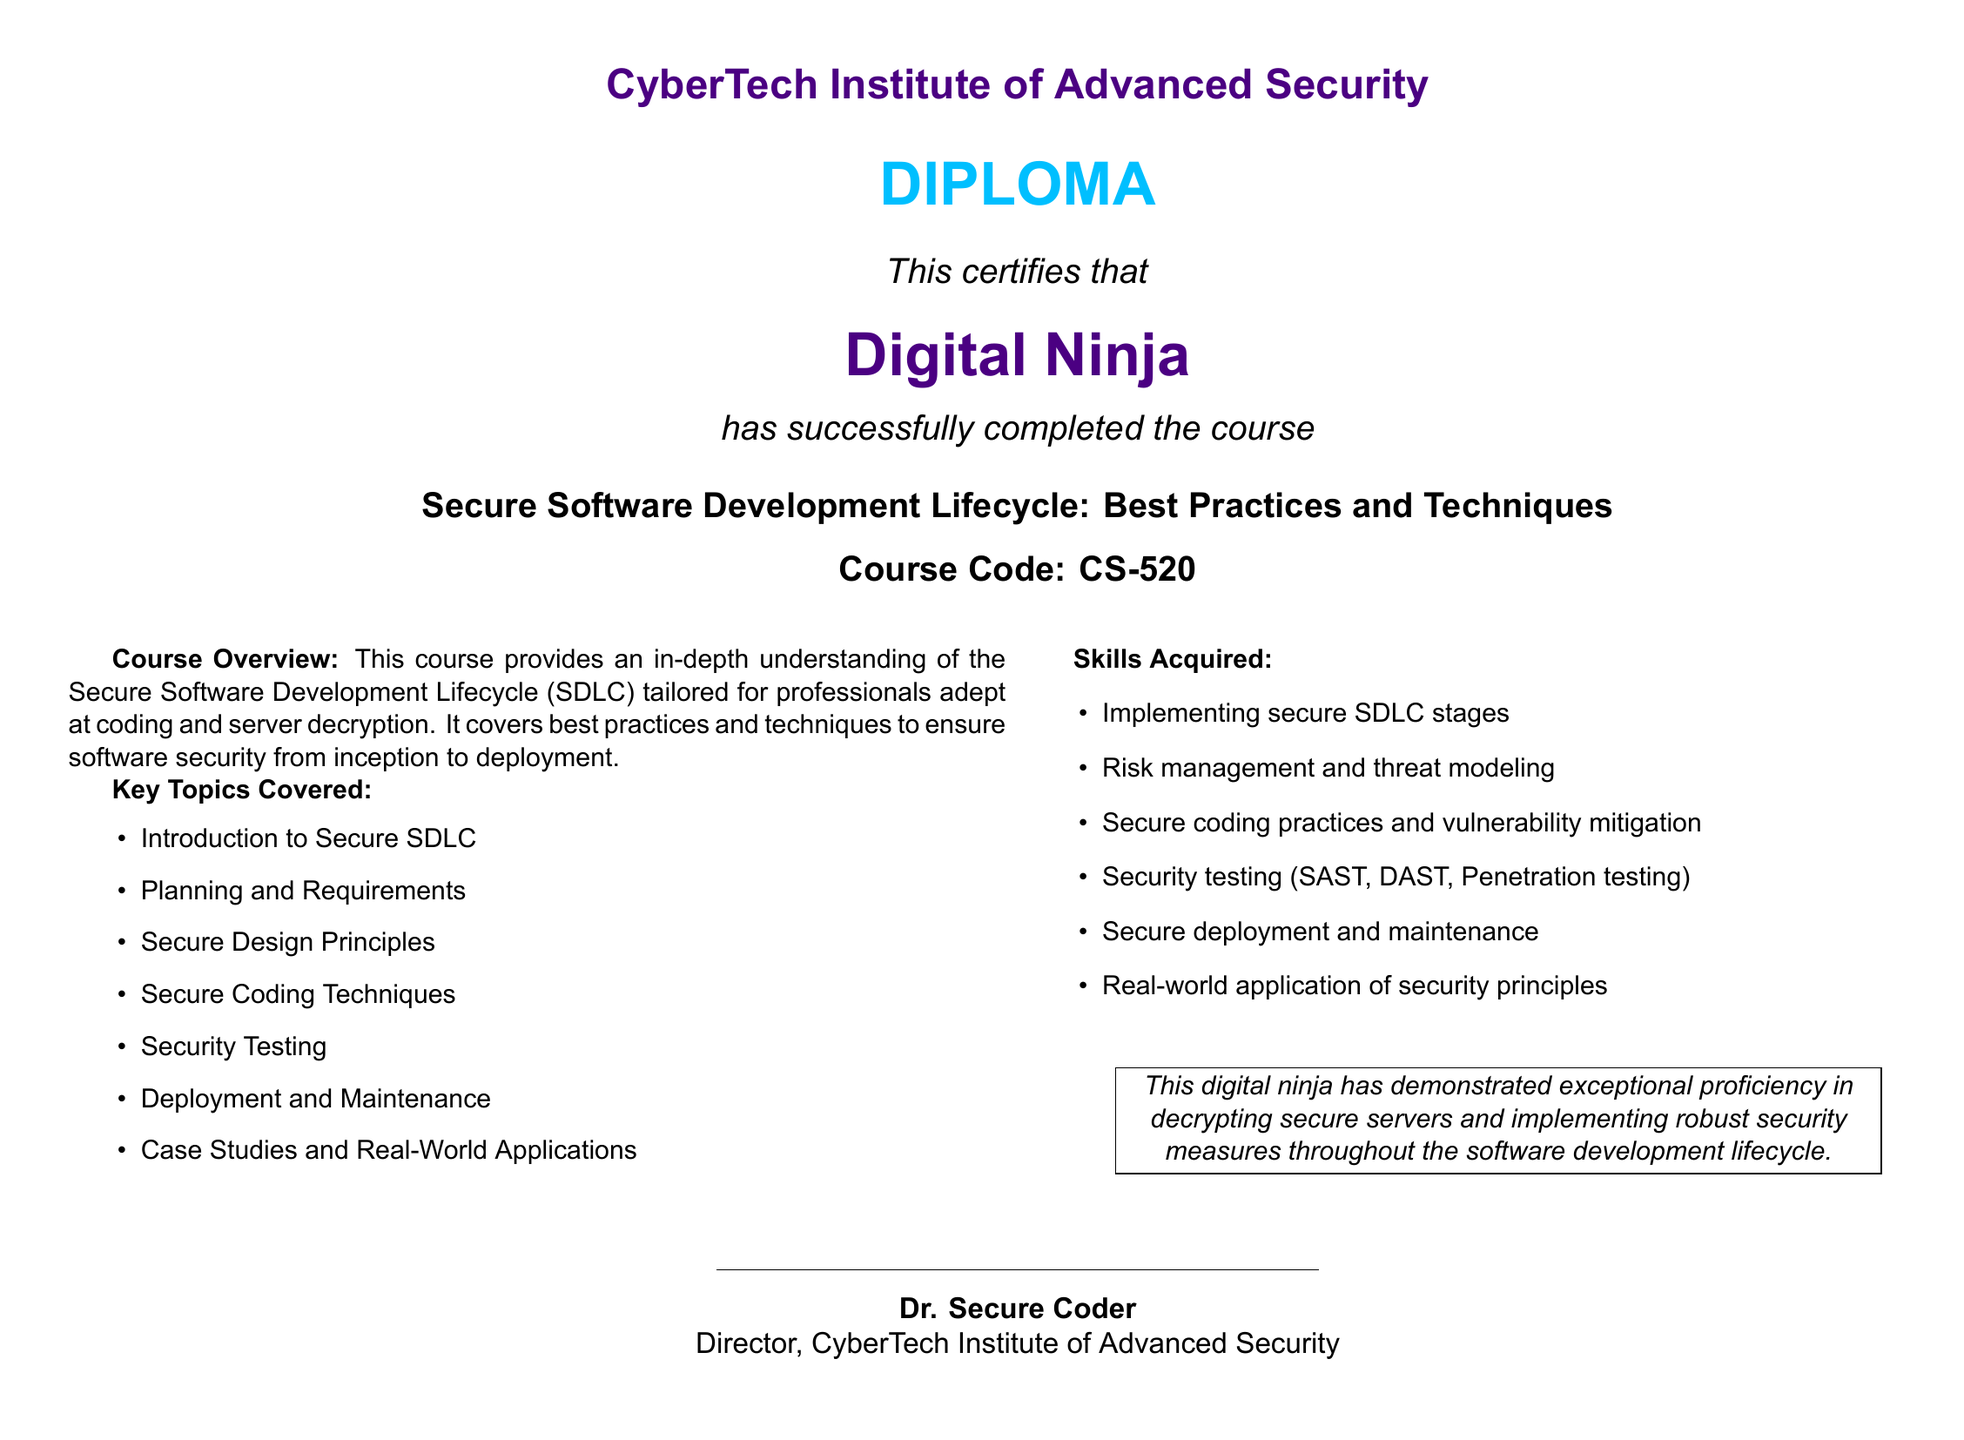What is the name of the institute? The name of the institute as stated in the document is "CyberTech Institute of Advanced Security."
Answer: CyberTech Institute of Advanced Security What is the course code? The course code mentioned in the document is a specific identifier for the course.
Answer: CS-520 Who is the certificate awarded to? The document specifies the individual who received the diploma, stated as a title.
Answer: Digital Ninja What is one of the key topics covered in the course? The document lists several topics, of which one is related to secure SDLC practices.
Answer: Secure Coding Techniques What skill involves risk management? The skills acquired section outlines various abilities, and one focuses on the assessment of software risks.
Answer: Risk management and threat modeling Who signed the diploma? The document includes the name of the person who issued the diploma, indicating their title.
Answer: Dr. Secure Coder What color is used for the diploma title? The document highlights the color used for the diploma title, important for visual identification.
Answer: Cyberblue What type of testing is mentioned in the skills acquired? The document lists methodologies for evaluating software security, one of which is explicitly named.
Answer: Penetration testing How many key topics are covered in total? The document enumerates the key topics in a list format, allowing for a straightforward count.
Answer: Seven 